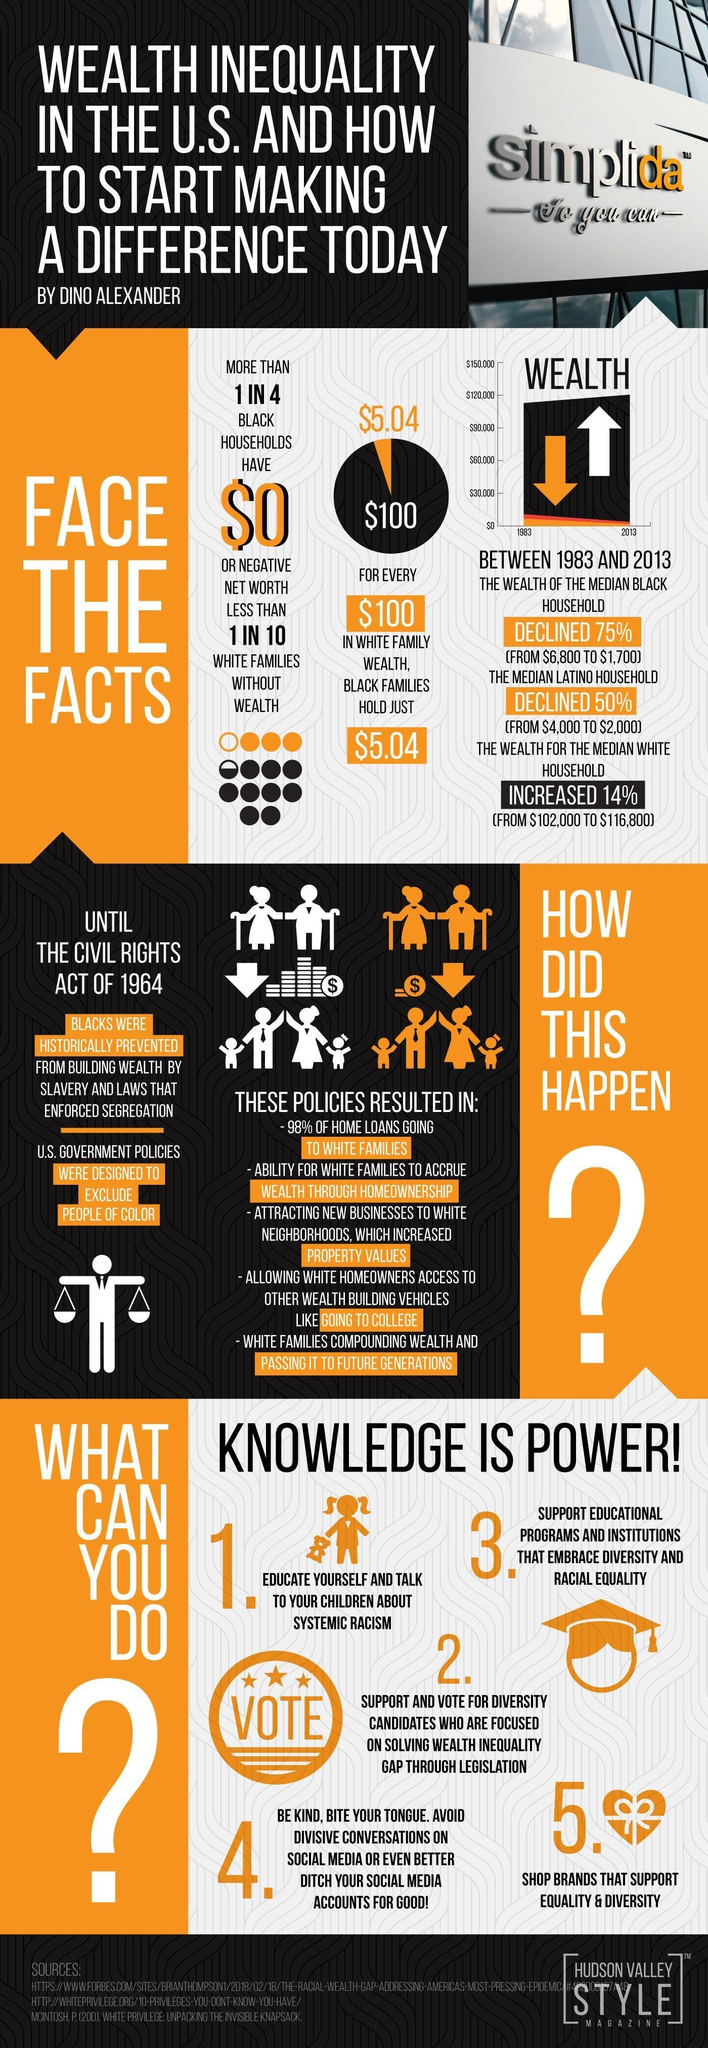How many points are listed to describe how we can reduce color race discrimination?
Answer the question with a short phrase. 5 How much is the wealth of Black Families when compared to White Families? $5.04 What percentage of Home loans were going to black Families? 2 What was the peculiarity of U.S Government policies? U.S. Government Policies were designed to exclude people of color 